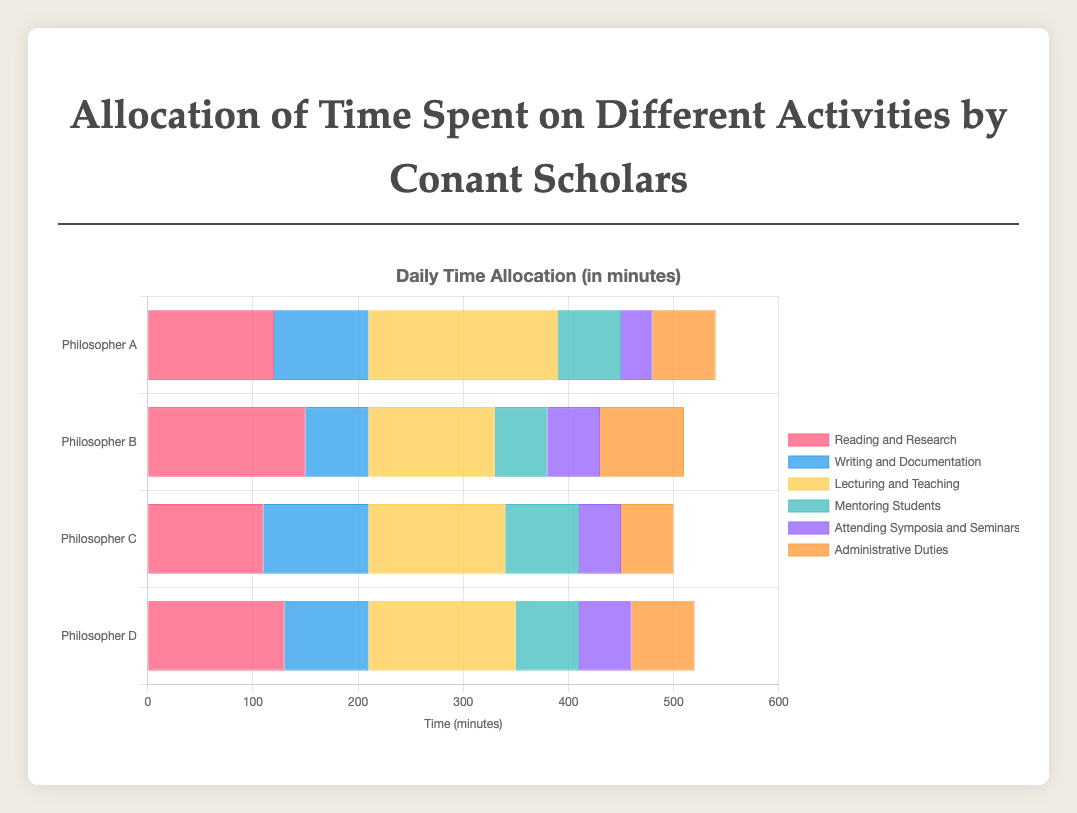What's the total time Philosopher A spends on "Reading and Research" and "Writing and Documentation"? Philosopher A spends 120 minutes on Reading and Research and 90 minutes on Writing and Documentation. Summing these gives 120 + 90 = 210 minutes.
Answer: 210 minutes Which activity occupies the most time for Philosopher D? For Philosopher D, the bars indicate the following times: Reading and Research (130), Writing and Documentation (80), Lecturing and Teaching (140), Mentoring Students (60), Attending Symposia and Seminars (50), and Administrative Duties (60). The most time is spent on Lecturing and Teaching at 140 minutes.
Answer: Lecturing and Teaching Among the philosophers, who spends the least time on "Mentoring Students"? The times spent on Mentoring Students are: Philosopher A (60), Philosopher B (50), Philosopher C (70), and Philosopher D (60). Philosopher B spends the least time at 50 minutes.
Answer: Philosopher B What is the average time allocated by Philosopher C across all activities? Add up the time across all activities for Philosopher C: 110 (Reading) + 100 (Writing) + 130 (Lecturing) + 70 (Mentoring) + 40 (Symposia) + 50 (Administrative) = 500 minutes. There are 6 activities, so average time = 500 / 6 ≈ 83.3 minutes.
Answer: 83.3 minutes Which philosopher spends more time on "Lecturing and Teaching," Philosopher A or Philosopher B? Philosopher A spends 180 minutes on Lecturing and Teaching, while Philosopher B spends 120 minutes. Philosopher A spends more time.
Answer: Philosopher A What is the combined time spent on "Administrative Duties" by Philosopher B and Philosopher C? Philosopher B spends 80 minutes and Philosopher C spends 50 minutes on Administrative Duties. Combined time is 80 + 50 = 130 minutes.
Answer: 130 minutes Compare the time spent on "Attending Symposia and Seminars" by Philosopher A and Philosopher D. Are they equal? Philosopher A spends 30 minutes and Philosopher D spends 50 minutes on Attending Symposia and Seminars. They are not equal.
Answer: No Which activity does Philosopher B spend the least time on? The times for Philosopher B are: Reading and Research (150), Writing and Documentation (60), Lecturing and Teaching (120), Mentoring Students (50), Attending Symposia and Seminars (50), Administrative Duties (80). The least time is spent on Mentoring Students and Attending Symposia and Seminars, both at 50 minutes.
Answer: Mentoring Students and Attending Symposia and Seminars How much more time does Philosopher C spend on "Writing and Documentation" than Philosopher B? Philosopher C spends 100 minutes on Writing and Documentation, while Philosopher B spends 60 minutes. The difference is 100 - 60 = 40 minutes.
Answer: 40 minutes 